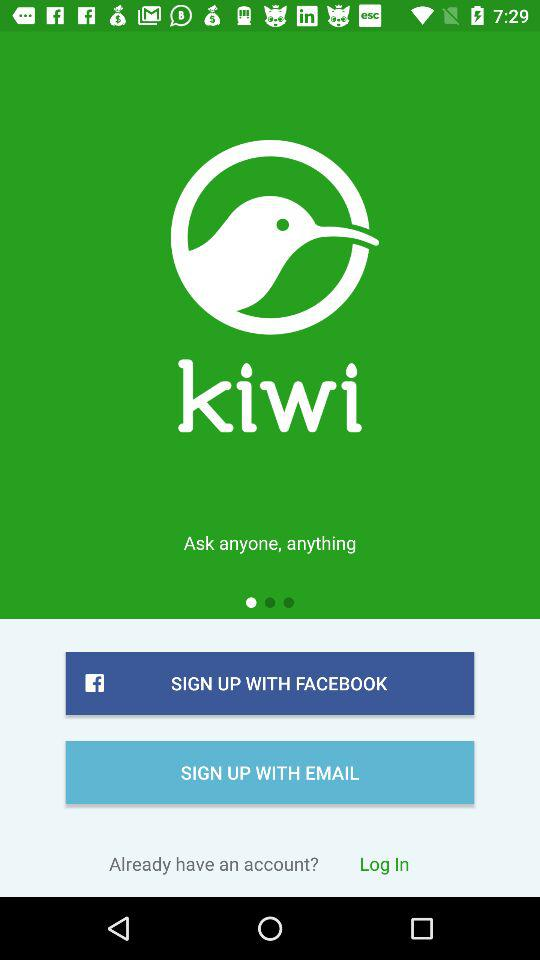What is the application name? The application name is "Kiwi". 